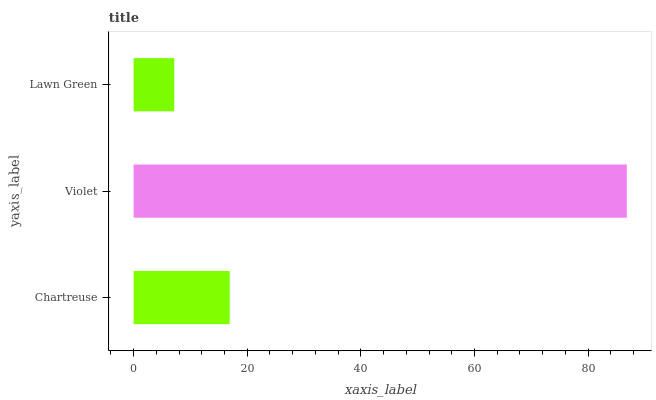Is Lawn Green the minimum?
Answer yes or no. Yes. Is Violet the maximum?
Answer yes or no. Yes. Is Violet the minimum?
Answer yes or no. No. Is Lawn Green the maximum?
Answer yes or no. No. Is Violet greater than Lawn Green?
Answer yes or no. Yes. Is Lawn Green less than Violet?
Answer yes or no. Yes. Is Lawn Green greater than Violet?
Answer yes or no. No. Is Violet less than Lawn Green?
Answer yes or no. No. Is Chartreuse the high median?
Answer yes or no. Yes. Is Chartreuse the low median?
Answer yes or no. Yes. Is Violet the high median?
Answer yes or no. No. Is Lawn Green the low median?
Answer yes or no. No. 